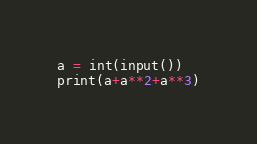Convert code to text. <code><loc_0><loc_0><loc_500><loc_500><_Python_>a = int(input())
print(a+a**2+a**3)</code> 